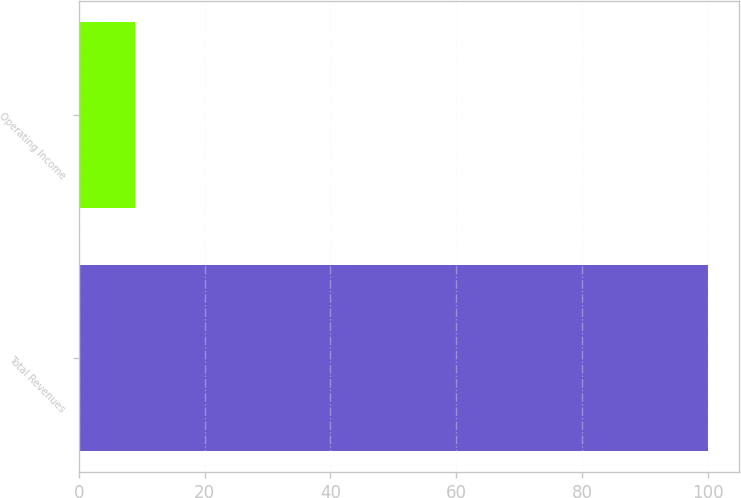<chart> <loc_0><loc_0><loc_500><loc_500><bar_chart><fcel>Total Revenues<fcel>Operating Income<nl><fcel>100<fcel>9<nl></chart> 